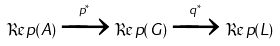<formula> <loc_0><loc_0><loc_500><loc_500>\Re p ( A ) \xrightarrow { p ^ { * } } \Re p ( G ) \xrightarrow { q ^ { * } } \Re p ( L )</formula> 